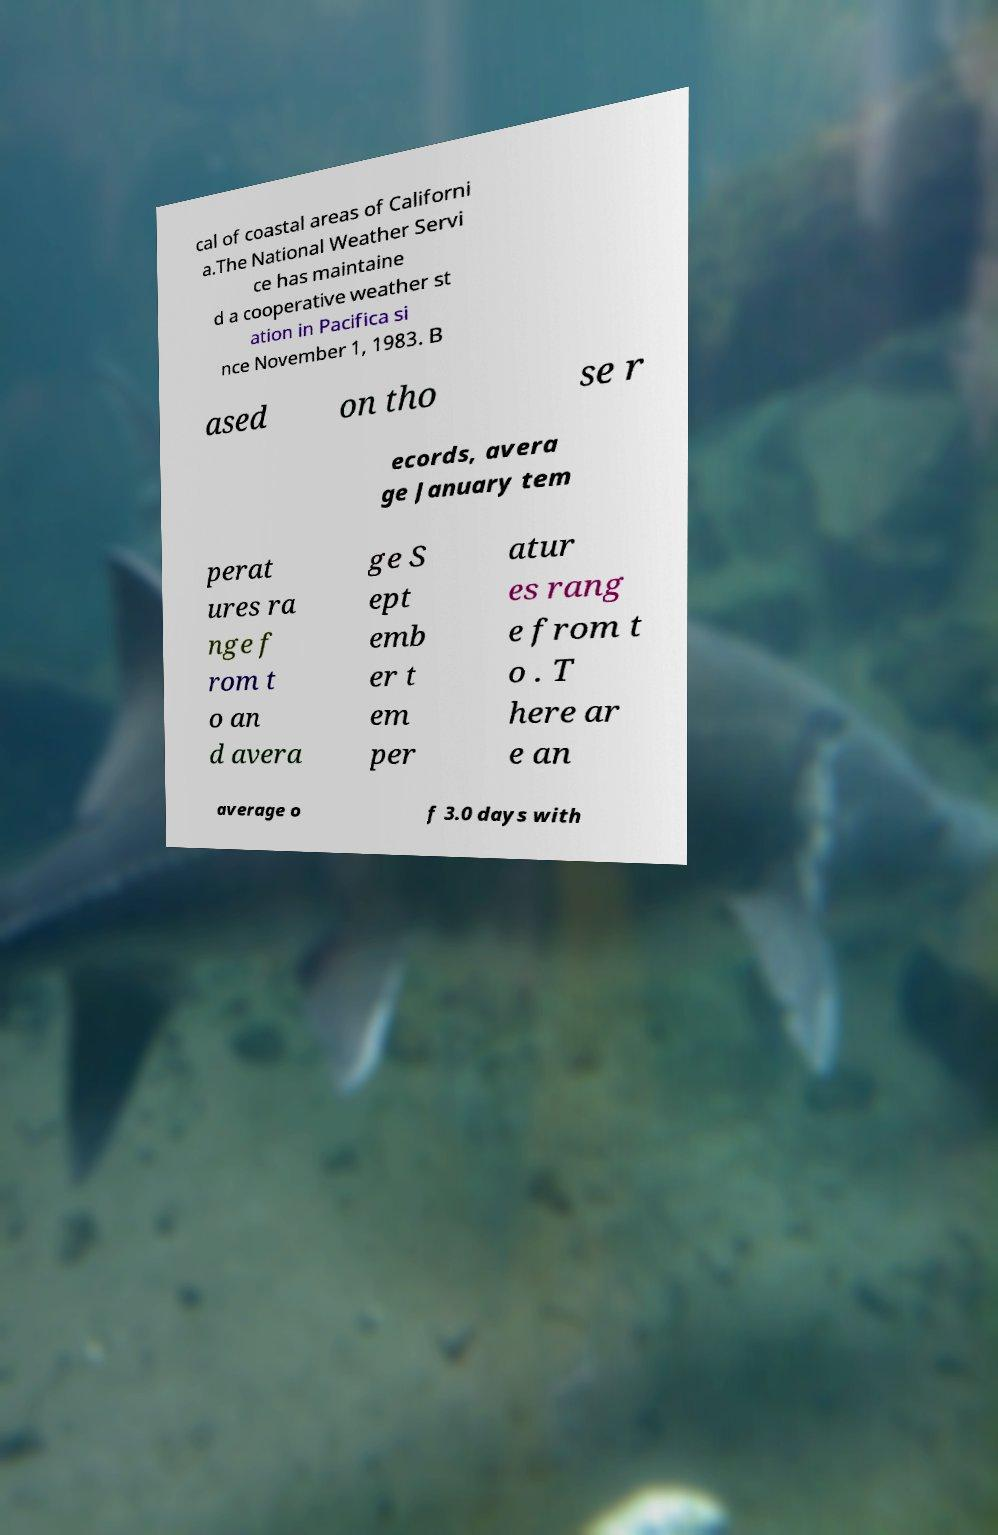Can you read and provide the text displayed in the image?This photo seems to have some interesting text. Can you extract and type it out for me? cal of coastal areas of Californi a.The National Weather Servi ce has maintaine d a cooperative weather st ation in Pacifica si nce November 1, 1983. B ased on tho se r ecords, avera ge January tem perat ures ra nge f rom t o an d avera ge S ept emb er t em per atur es rang e from t o . T here ar e an average o f 3.0 days with 